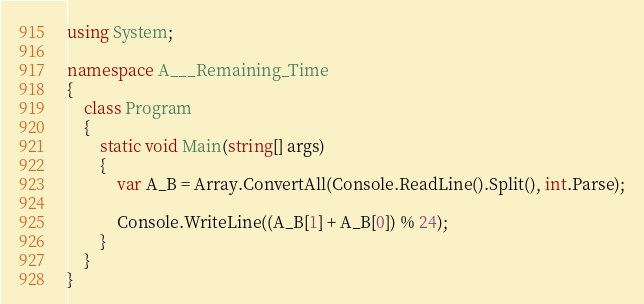<code> <loc_0><loc_0><loc_500><loc_500><_C#_>using System;

namespace A___Remaining_Time
{
    class Program
    {
        static void Main(string[] args)
        {
            var A_B = Array.ConvertAll(Console.ReadLine().Split(), int.Parse);

            Console.WriteLine((A_B[1] + A_B[0]) % 24);
        }
    }
}
</code> 